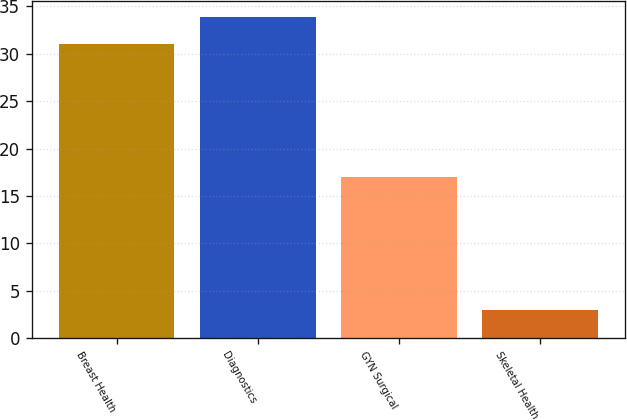Convert chart to OTSL. <chart><loc_0><loc_0><loc_500><loc_500><bar_chart><fcel>Breast Health<fcel>Diagnostics<fcel>GYN Surgical<fcel>Skeletal Health<nl><fcel>31<fcel>33.9<fcel>17<fcel>3<nl></chart> 